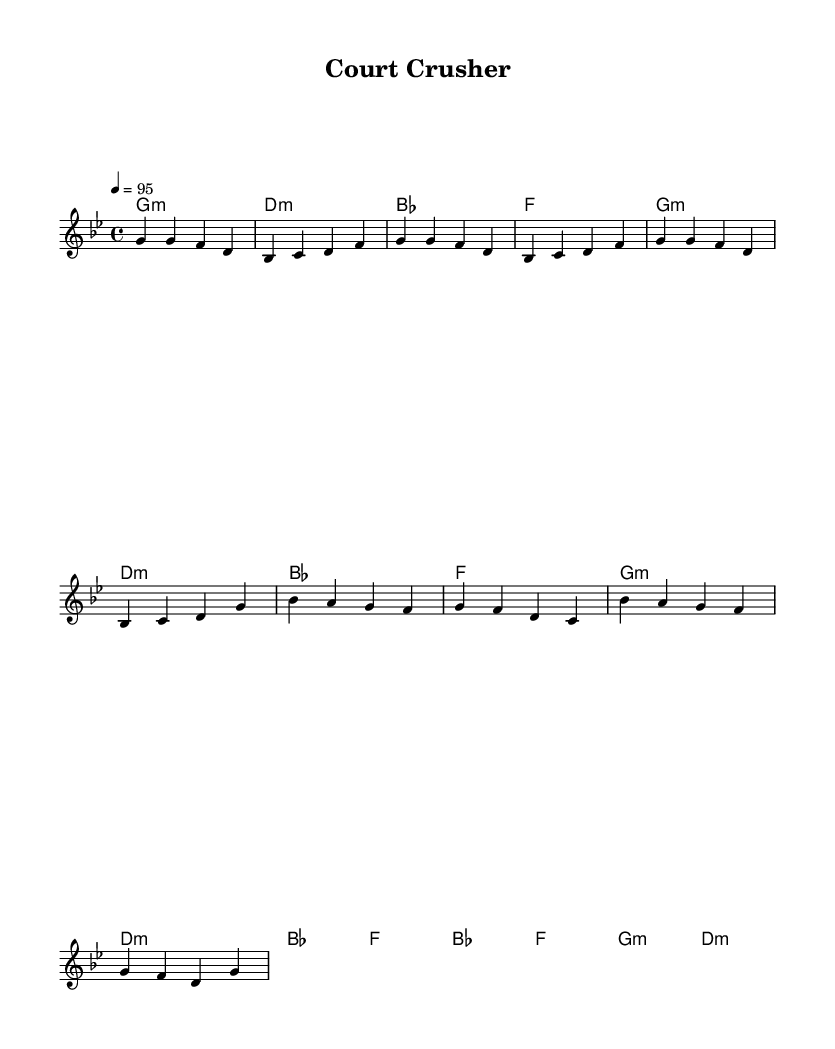What is the key signature of this music? The key signature is G minor, which has two flats (B flat and E flat). This is evident from the indication of G minor at the beginning of the score.
Answer: G minor What is the time signature of this music? The time signature is 4/4, shown at the beginning of the score. This indicates that there are four beats in a measure and the quarter note receives one beat.
Answer: 4/4 What is the tempo marking for this piece? The tempo marking is 4 equals 95, indicating the speed of the piece. This means there should be 95 beats per minute, with each beat being a quarter note.
Answer: 95 How many measures are there in the chorus? The chorus consists of four measures, as can be counted from the notation given in that section of the music. Each set of notes corresponds sequentially to measures.
Answer: 4 What is the first chord in the intro section? The first chord in the intro section is G minor, indicated at the beginning of the harmony part, which corresponds to the melody notes that follow it.
Answer: G minor Which chord is played in the final measure of the chorus? The final measure of the chorus features a G minor chord according to the chord progression shown, which concludes the section with this harmony.
Answer: G minor How many distinct sections are in this composition? There are three distinct sections in this composition: the intro, the verse, and the chorus. Each section has its specific musical characteristics and repeats at different points in the score.
Answer: 3 